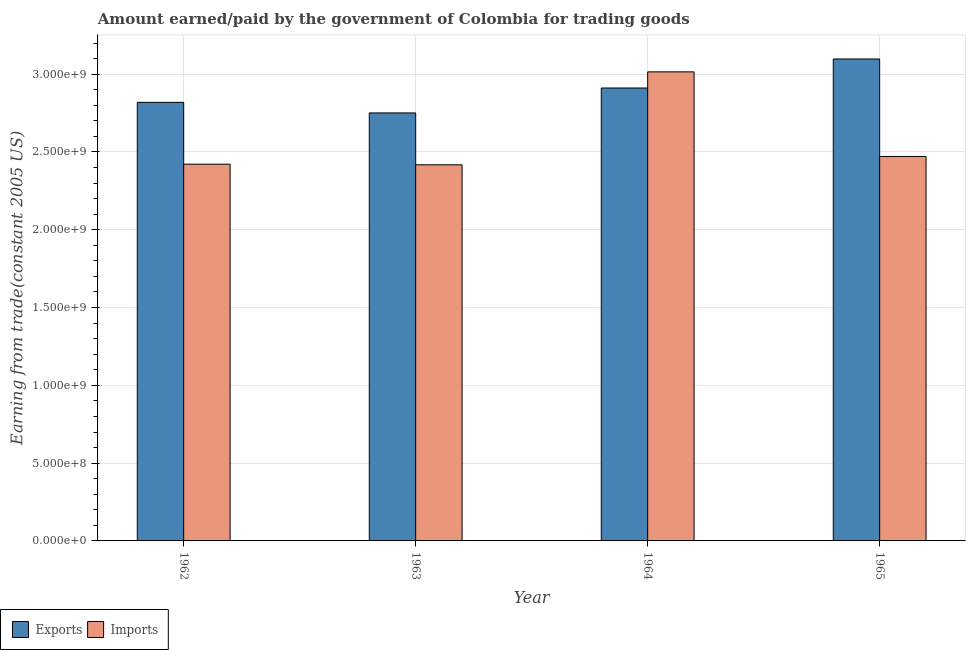How many groups of bars are there?
Offer a terse response. 4. Are the number of bars per tick equal to the number of legend labels?
Offer a terse response. Yes. How many bars are there on the 1st tick from the right?
Your answer should be compact. 2. What is the label of the 2nd group of bars from the left?
Provide a succinct answer. 1963. What is the amount paid for imports in 1965?
Keep it short and to the point. 2.47e+09. Across all years, what is the maximum amount earned from exports?
Provide a succinct answer. 3.10e+09. Across all years, what is the minimum amount paid for imports?
Keep it short and to the point. 2.42e+09. In which year was the amount paid for imports maximum?
Keep it short and to the point. 1964. What is the total amount earned from exports in the graph?
Provide a succinct answer. 1.16e+1. What is the difference between the amount earned from exports in 1963 and that in 1965?
Ensure brevity in your answer.  -3.47e+08. What is the difference between the amount earned from exports in 1965 and the amount paid for imports in 1964?
Your response must be concise. 1.87e+08. What is the average amount earned from exports per year?
Offer a terse response. 2.89e+09. In the year 1963, what is the difference between the amount paid for imports and amount earned from exports?
Provide a succinct answer. 0. What is the ratio of the amount paid for imports in 1963 to that in 1965?
Make the answer very short. 0.98. What is the difference between the highest and the second highest amount earned from exports?
Your answer should be compact. 1.87e+08. What is the difference between the highest and the lowest amount earned from exports?
Make the answer very short. 3.47e+08. In how many years, is the amount earned from exports greater than the average amount earned from exports taken over all years?
Provide a succinct answer. 2. What does the 1st bar from the left in 1964 represents?
Keep it short and to the point. Exports. What does the 2nd bar from the right in 1963 represents?
Your answer should be very brief. Exports. Are all the bars in the graph horizontal?
Offer a very short reply. No. How many years are there in the graph?
Ensure brevity in your answer.  4. Does the graph contain any zero values?
Your response must be concise. No. Where does the legend appear in the graph?
Keep it short and to the point. Bottom left. How many legend labels are there?
Your answer should be compact. 2. What is the title of the graph?
Give a very brief answer. Amount earned/paid by the government of Colombia for trading goods. Does "Urban" appear as one of the legend labels in the graph?
Make the answer very short. No. What is the label or title of the Y-axis?
Your response must be concise. Earning from trade(constant 2005 US). What is the Earning from trade(constant 2005 US) of Exports in 1962?
Your answer should be very brief. 2.82e+09. What is the Earning from trade(constant 2005 US) of Imports in 1962?
Make the answer very short. 2.42e+09. What is the Earning from trade(constant 2005 US) of Exports in 1963?
Keep it short and to the point. 2.75e+09. What is the Earning from trade(constant 2005 US) in Imports in 1963?
Your response must be concise. 2.42e+09. What is the Earning from trade(constant 2005 US) in Exports in 1964?
Your answer should be very brief. 2.91e+09. What is the Earning from trade(constant 2005 US) in Imports in 1964?
Provide a short and direct response. 3.01e+09. What is the Earning from trade(constant 2005 US) of Exports in 1965?
Make the answer very short. 3.10e+09. What is the Earning from trade(constant 2005 US) of Imports in 1965?
Keep it short and to the point. 2.47e+09. Across all years, what is the maximum Earning from trade(constant 2005 US) in Exports?
Offer a very short reply. 3.10e+09. Across all years, what is the maximum Earning from trade(constant 2005 US) of Imports?
Give a very brief answer. 3.01e+09. Across all years, what is the minimum Earning from trade(constant 2005 US) in Exports?
Ensure brevity in your answer.  2.75e+09. Across all years, what is the minimum Earning from trade(constant 2005 US) of Imports?
Ensure brevity in your answer.  2.42e+09. What is the total Earning from trade(constant 2005 US) in Exports in the graph?
Your response must be concise. 1.16e+1. What is the total Earning from trade(constant 2005 US) of Imports in the graph?
Offer a very short reply. 1.03e+1. What is the difference between the Earning from trade(constant 2005 US) in Exports in 1962 and that in 1963?
Provide a short and direct response. 6.81e+07. What is the difference between the Earning from trade(constant 2005 US) of Imports in 1962 and that in 1963?
Ensure brevity in your answer.  3.93e+06. What is the difference between the Earning from trade(constant 2005 US) of Exports in 1962 and that in 1964?
Offer a terse response. -9.21e+07. What is the difference between the Earning from trade(constant 2005 US) in Imports in 1962 and that in 1964?
Provide a succinct answer. -5.93e+08. What is the difference between the Earning from trade(constant 2005 US) of Exports in 1962 and that in 1965?
Your response must be concise. -2.79e+08. What is the difference between the Earning from trade(constant 2005 US) of Imports in 1962 and that in 1965?
Offer a terse response. -4.96e+07. What is the difference between the Earning from trade(constant 2005 US) of Exports in 1963 and that in 1964?
Give a very brief answer. -1.60e+08. What is the difference between the Earning from trade(constant 2005 US) in Imports in 1963 and that in 1964?
Your answer should be compact. -5.97e+08. What is the difference between the Earning from trade(constant 2005 US) in Exports in 1963 and that in 1965?
Give a very brief answer. -3.47e+08. What is the difference between the Earning from trade(constant 2005 US) of Imports in 1963 and that in 1965?
Make the answer very short. -5.35e+07. What is the difference between the Earning from trade(constant 2005 US) in Exports in 1964 and that in 1965?
Make the answer very short. -1.87e+08. What is the difference between the Earning from trade(constant 2005 US) in Imports in 1964 and that in 1965?
Provide a succinct answer. 5.44e+08. What is the difference between the Earning from trade(constant 2005 US) of Exports in 1962 and the Earning from trade(constant 2005 US) of Imports in 1963?
Make the answer very short. 4.01e+08. What is the difference between the Earning from trade(constant 2005 US) of Exports in 1962 and the Earning from trade(constant 2005 US) of Imports in 1964?
Ensure brevity in your answer.  -1.96e+08. What is the difference between the Earning from trade(constant 2005 US) of Exports in 1962 and the Earning from trade(constant 2005 US) of Imports in 1965?
Provide a short and direct response. 3.48e+08. What is the difference between the Earning from trade(constant 2005 US) in Exports in 1963 and the Earning from trade(constant 2005 US) in Imports in 1964?
Give a very brief answer. -2.64e+08. What is the difference between the Earning from trade(constant 2005 US) in Exports in 1963 and the Earning from trade(constant 2005 US) in Imports in 1965?
Keep it short and to the point. 2.80e+08. What is the difference between the Earning from trade(constant 2005 US) in Exports in 1964 and the Earning from trade(constant 2005 US) in Imports in 1965?
Keep it short and to the point. 4.40e+08. What is the average Earning from trade(constant 2005 US) of Exports per year?
Your answer should be compact. 2.89e+09. What is the average Earning from trade(constant 2005 US) of Imports per year?
Provide a short and direct response. 2.58e+09. In the year 1962, what is the difference between the Earning from trade(constant 2005 US) in Exports and Earning from trade(constant 2005 US) in Imports?
Make the answer very short. 3.98e+08. In the year 1963, what is the difference between the Earning from trade(constant 2005 US) of Exports and Earning from trade(constant 2005 US) of Imports?
Provide a succinct answer. 3.33e+08. In the year 1964, what is the difference between the Earning from trade(constant 2005 US) in Exports and Earning from trade(constant 2005 US) in Imports?
Make the answer very short. -1.04e+08. In the year 1965, what is the difference between the Earning from trade(constant 2005 US) in Exports and Earning from trade(constant 2005 US) in Imports?
Your answer should be very brief. 6.27e+08. What is the ratio of the Earning from trade(constant 2005 US) in Exports in 1962 to that in 1963?
Offer a terse response. 1.02. What is the ratio of the Earning from trade(constant 2005 US) in Imports in 1962 to that in 1963?
Make the answer very short. 1. What is the ratio of the Earning from trade(constant 2005 US) of Exports in 1962 to that in 1964?
Keep it short and to the point. 0.97. What is the ratio of the Earning from trade(constant 2005 US) of Imports in 1962 to that in 1964?
Keep it short and to the point. 0.8. What is the ratio of the Earning from trade(constant 2005 US) of Exports in 1962 to that in 1965?
Give a very brief answer. 0.91. What is the ratio of the Earning from trade(constant 2005 US) in Imports in 1962 to that in 1965?
Offer a very short reply. 0.98. What is the ratio of the Earning from trade(constant 2005 US) in Exports in 1963 to that in 1964?
Keep it short and to the point. 0.94. What is the ratio of the Earning from trade(constant 2005 US) of Imports in 1963 to that in 1964?
Your response must be concise. 0.8. What is the ratio of the Earning from trade(constant 2005 US) of Exports in 1963 to that in 1965?
Your response must be concise. 0.89. What is the ratio of the Earning from trade(constant 2005 US) in Imports in 1963 to that in 1965?
Your answer should be compact. 0.98. What is the ratio of the Earning from trade(constant 2005 US) of Exports in 1964 to that in 1965?
Your answer should be compact. 0.94. What is the ratio of the Earning from trade(constant 2005 US) in Imports in 1964 to that in 1965?
Your answer should be compact. 1.22. What is the difference between the highest and the second highest Earning from trade(constant 2005 US) in Exports?
Offer a terse response. 1.87e+08. What is the difference between the highest and the second highest Earning from trade(constant 2005 US) of Imports?
Your answer should be compact. 5.44e+08. What is the difference between the highest and the lowest Earning from trade(constant 2005 US) in Exports?
Make the answer very short. 3.47e+08. What is the difference between the highest and the lowest Earning from trade(constant 2005 US) of Imports?
Your answer should be very brief. 5.97e+08. 